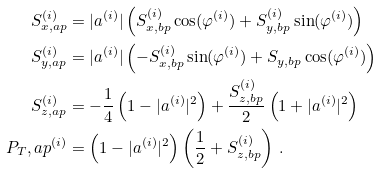Convert formula to latex. <formula><loc_0><loc_0><loc_500><loc_500>S _ { x , a p } ^ { ( i ) } & = | a ^ { ( i ) } | \left ( S _ { x , b p } ^ { ( i ) } \cos ( \varphi ^ { ( i ) } ) + S _ { y , b p } ^ { ( i ) } \sin ( \varphi ^ { ( i ) } ) \right ) \\ S _ { y , a p } ^ { ( i ) } & = | a ^ { ( i ) } | \left ( - S _ { x , b p } ^ { ( i ) } \sin ( \varphi ^ { ( i ) } ) + S _ { y , b p } \cos ( \varphi ^ { ( i ) } ) \right ) \\ S _ { z , a p } ^ { ( i ) } & = - \frac { 1 } { 4 } \left ( 1 - | a ^ { ( i ) } | ^ { 2 } \right ) + \frac { S _ { z , b p } ^ { ( i ) } } { 2 } \left ( 1 + | a ^ { ( i ) } | ^ { 2 } \right ) \\ P _ { T } , a p ^ { ( i ) } & = \left ( 1 - | a ^ { ( i ) } | ^ { 2 } \right ) \left ( \frac { 1 } { 2 } + S _ { z , b p } ^ { ( i ) } \right ) \, .</formula> 